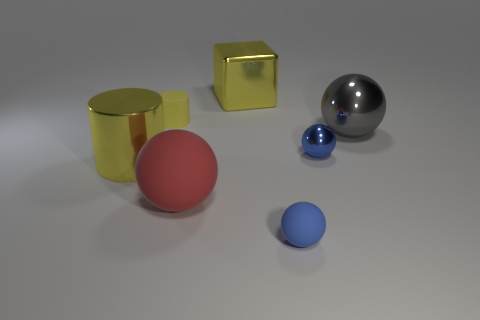What number of objects are either metal things or gray shiny spheres?
Make the answer very short. 4. Is the big cube the same color as the matte cylinder?
Offer a very short reply. Yes. Are there any other things that have the same size as the blue shiny ball?
Give a very brief answer. Yes. There is a metal thing that is behind the yellow rubber cylinder behind the yellow metallic cylinder; what shape is it?
Your answer should be very brief. Cube. Is the number of tiny red things less than the number of big gray objects?
Make the answer very short. Yes. There is a shiny thing that is left of the blue rubber ball and on the right side of the yellow metallic cylinder; what size is it?
Offer a very short reply. Large. Is the size of the yellow rubber object the same as the blue shiny thing?
Ensure brevity in your answer.  Yes. There is a cylinder that is to the left of the tiny yellow cylinder; does it have the same color as the cube?
Make the answer very short. Yes. How many objects are in front of the large red ball?
Provide a succinct answer. 1. Is the number of yellow things greater than the number of metal spheres?
Keep it short and to the point. Yes. 